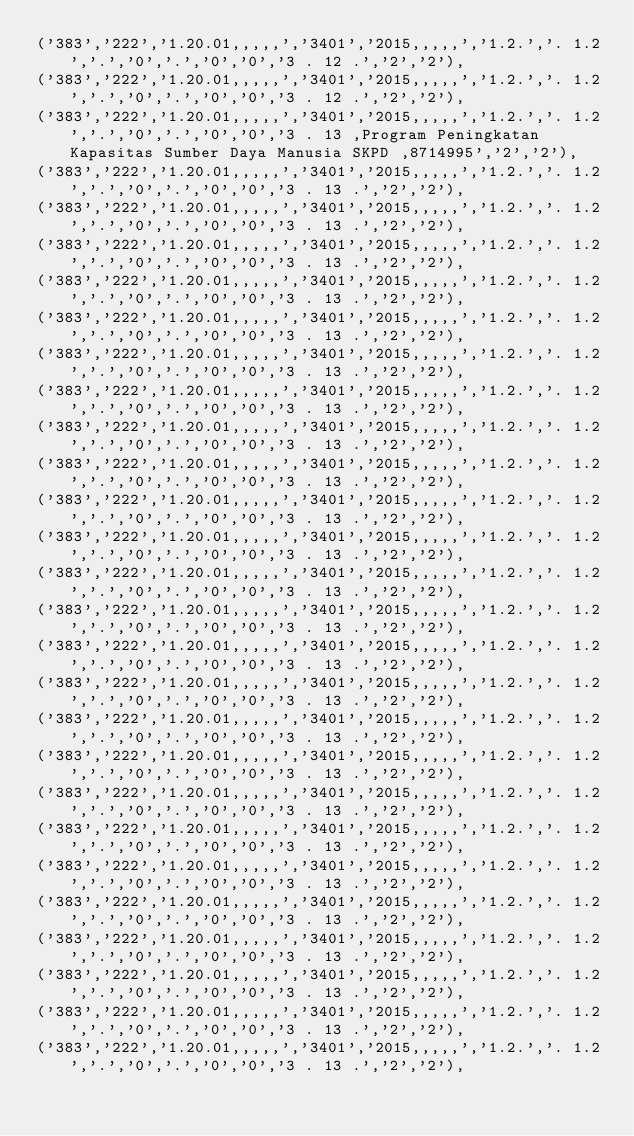<code> <loc_0><loc_0><loc_500><loc_500><_SQL_>('383','222','1.20.01,,,,,','3401','2015,,,,,','1.2.','. 1.2','.','0','.','0','0','3 . 12 .','2','2'),
('383','222','1.20.01,,,,,','3401','2015,,,,,','1.2.','. 1.2','.','0','.','0','0','3 . 12 .','2','2'),
('383','222','1.20.01,,,,,','3401','2015,,,,,','1.2.','. 1.2','.','0','.','0','0','3 . 13 ,Program Peningkatan Kapasitas Sumber Daya Manusia SKPD ,8714995','2','2'),
('383','222','1.20.01,,,,,','3401','2015,,,,,','1.2.','. 1.2','.','0','.','0','0','3 . 13 .','2','2'),
('383','222','1.20.01,,,,,','3401','2015,,,,,','1.2.','. 1.2','.','0','.','0','0','3 . 13 .','2','2'),
('383','222','1.20.01,,,,,','3401','2015,,,,,','1.2.','. 1.2','.','0','.','0','0','3 . 13 .','2','2'),
('383','222','1.20.01,,,,,','3401','2015,,,,,','1.2.','. 1.2','.','0','.','0','0','3 . 13 .','2','2'),
('383','222','1.20.01,,,,,','3401','2015,,,,,','1.2.','. 1.2','.','0','.','0','0','3 . 13 .','2','2'),
('383','222','1.20.01,,,,,','3401','2015,,,,,','1.2.','. 1.2','.','0','.','0','0','3 . 13 .','2','2'),
('383','222','1.20.01,,,,,','3401','2015,,,,,','1.2.','. 1.2','.','0','.','0','0','3 . 13 .','2','2'),
('383','222','1.20.01,,,,,','3401','2015,,,,,','1.2.','. 1.2','.','0','.','0','0','3 . 13 .','2','2'),
('383','222','1.20.01,,,,,','3401','2015,,,,,','1.2.','. 1.2','.','0','.','0','0','3 . 13 .','2','2'),
('383','222','1.20.01,,,,,','3401','2015,,,,,','1.2.','. 1.2','.','0','.','0','0','3 . 13 .','2','2'),
('383','222','1.20.01,,,,,','3401','2015,,,,,','1.2.','. 1.2','.','0','.','0','0','3 . 13 .','2','2'),
('383','222','1.20.01,,,,,','3401','2015,,,,,','1.2.','. 1.2','.','0','.','0','0','3 . 13 .','2','2'),
('383','222','1.20.01,,,,,','3401','2015,,,,,','1.2.','. 1.2','.','0','.','0','0','3 . 13 .','2','2'),
('383','222','1.20.01,,,,,','3401','2015,,,,,','1.2.','. 1.2','.','0','.','0','0','3 . 13 .','2','2'),
('383','222','1.20.01,,,,,','3401','2015,,,,,','1.2.','. 1.2','.','0','.','0','0','3 . 13 .','2','2'),
('383','222','1.20.01,,,,,','3401','2015,,,,,','1.2.','. 1.2','.','0','.','0','0','3 . 13 .','2','2'),
('383','222','1.20.01,,,,,','3401','2015,,,,,','1.2.','. 1.2','.','0','.','0','0','3 . 13 .','2','2'),
('383','222','1.20.01,,,,,','3401','2015,,,,,','1.2.','. 1.2','.','0','.','0','0','3 . 13 .','2','2'),
('383','222','1.20.01,,,,,','3401','2015,,,,,','1.2.','. 1.2','.','0','.','0','0','3 . 13 .','2','2'),
('383','222','1.20.01,,,,,','3401','2015,,,,,','1.2.','. 1.2','.','0','.','0','0','3 . 13 .','2','2'),
('383','222','1.20.01,,,,,','3401','2015,,,,,','1.2.','. 1.2','.','0','.','0','0','3 . 13 .','2','2'),
('383','222','1.20.01,,,,,','3401','2015,,,,,','1.2.','. 1.2','.','0','.','0','0','3 . 13 .','2','2'),
('383','222','1.20.01,,,,,','3401','2015,,,,,','1.2.','. 1.2','.','0','.','0','0','3 . 13 .','2','2'),
('383','222','1.20.01,,,,,','3401','2015,,,,,','1.2.','. 1.2','.','0','.','0','0','3 . 13 .','2','2'),
('383','222','1.20.01,,,,,','3401','2015,,,,,','1.2.','. 1.2','.','0','.','0','0','3 . 13 .','2','2'),</code> 